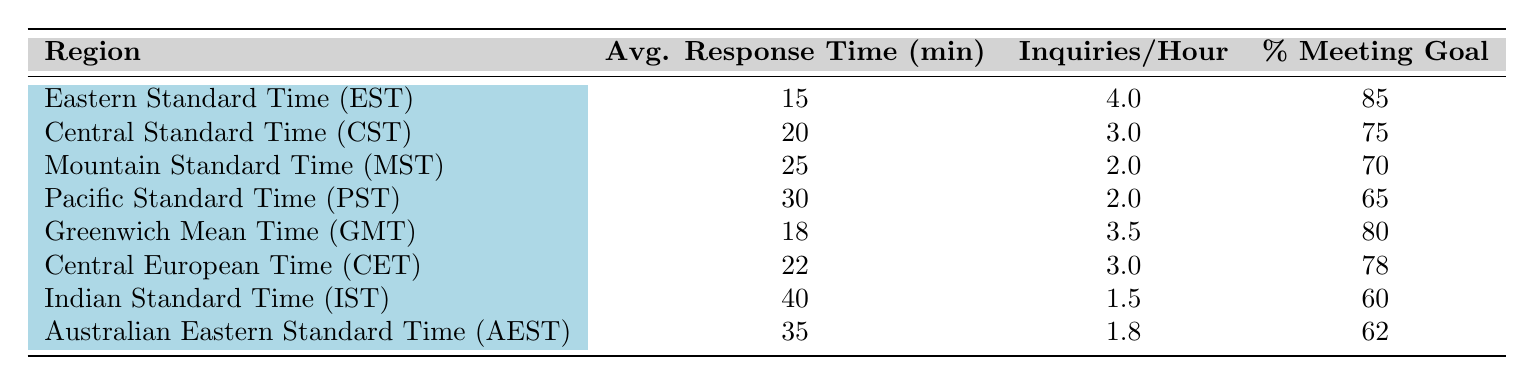What is the average response time for inquiries in the Eastern Standard Time region? The table indicates the average response time for the Eastern Standard Time (EST) region is 15 minutes. This value is directly reported in the table under the "Avg. Response Time (min)" column for the EST row.
Answer: 15 minutes Which region has the highest percentage of meeting the response time goal? By looking at the "Percentage Meeting Goal" column, the highest percentage is 85%, which is associated with the Eastern Standard Time (EST) region. This is the maximum value in that column.
Answer: Eastern Standard Time (EST) What is the difference in average response time between the Pacific Standard Time and the Central Standard Time regions? The average response time for Pacific Standard Time (PST) is 30 minutes and for Central Standard Time (CST) is 20 minutes. To find the difference, subtract CST from PST: 30 - 20 = 10 minutes.
Answer: 10 minutes Is it true that the Indian Standard Time region has the lowest percentage of inquiries meeting the response time goal? Upon examining the "Percentage Meeting Goal" column, the Indian Standard Time (IST) region shows a percentage of 60. Comparing this with other regions, it is indeed the lowest value in that column, confirming the statement as true.
Answer: Yes If we average the inquiries handled per hour of all regions, what is the result? To find the average, first sum the inquiries handled per hour from all regions: 4 + 3 + 2 + 2 + 3.5 + 3 + 1.5 + 1.8 = 21.8. There are 8 regions in total. Now, divide the total by 8: 21.8 / 8 = 2.725 inquiries per hour on average.
Answer: 2.725 inquiries per hour 